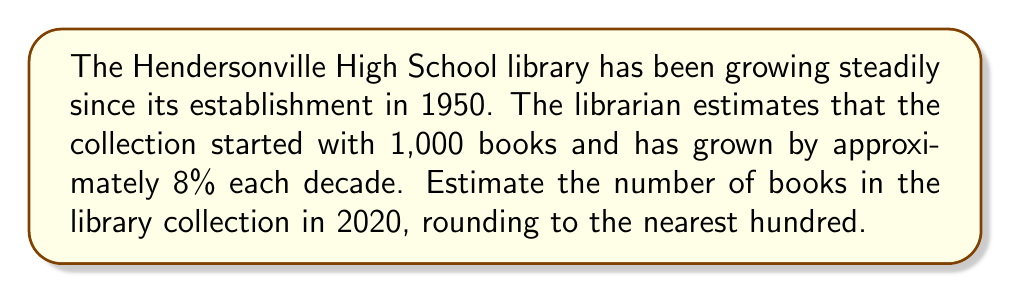Teach me how to tackle this problem. To solve this problem, we need to calculate the growth of the library collection over seven decades (1950 to 2020).

Let's use the compound interest formula:
$$A = P(1 + r)^n$$
Where:
$A$ = final amount
$P$ = principal (initial amount)
$r$ = growth rate per period
$n$ = number of periods

Given:
$P = 1,000$ (initial number of books in 1950)
$r = 0.08$ (8% growth per decade)
$n = 7$ (number of decades from 1950 to 2020)

Plugging these values into the formula:

$$A = 1,000(1 + 0.08)^7$$

$$A = 1,000(1.08)^7$$

$$A = 1,000 \times 1.7138$$

$$A = 1,713.8$$

Rounding to the nearest hundred:

$$A \approx 1,700$$
Answer: The estimated number of books in the Hendersonville High School library collection in 2020 is approximately 1,700 books. 